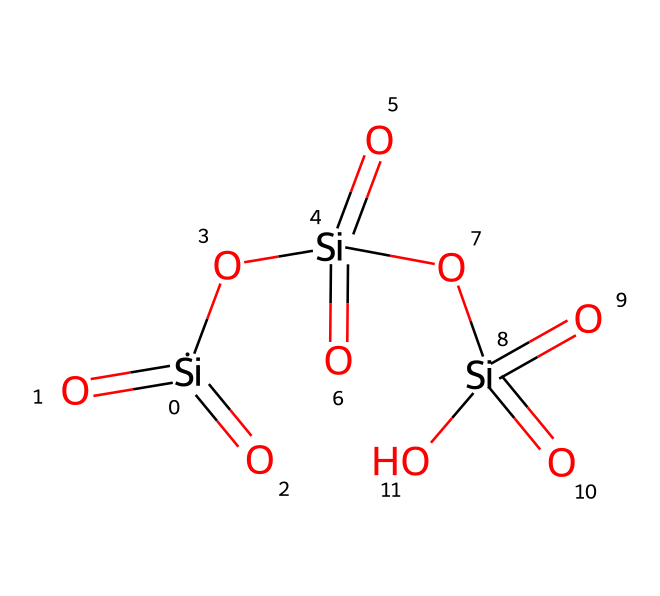How many silicon atoms are present in the structure? The SMILES representation shows three instances of the silicon atom (Si), which are clearly depicted in the structure. Each silicon is bonded with oxygen and a hydroxyl group.
Answer: three What is the total number of oxygen atoms in the chemical? Analyzing the SMILES structure, each silicon atom is surrounded by four oxygen atoms: three from the silicate bonds and one as a hydroxyl (OH). Therefore, the total count is three silicon atoms multiplied by four oxygen atoms, resulting in twelve oxygen atoms.
Answer: twelve What type of chemical structure does silicon dioxide have? The visual representation indicates a tetrahedral coordination, typical for silicon dioxide, with silicon atoms surrounded by oxygen atoms forming a networked structure that contributes to its properties.
Answer: tetrahedral Does this structure show any hydrogen atoms? The chemical appears to have hydroxyl groups (OH), indicating the presence of hydrogen atoms, but specifically in the listed SMILES, there are no explicitly represented hydrogen atoms outside of those in hydroxyl groups.
Answer: yes What crystal system is silicon dioxide typically associated with? Silicon dioxide commonly crystallizes in a tetragonal or hexagonal system depending on its form (quartz or tridymite, respectively). Therefore, it typically fits into one of these crystal systems based on its arrangement.
Answer: tetragonal Is this structure likely to contribute to soundproofing materials? The resilience and structural integrity of silicon dioxide in the form used for studio applications allow it to effectively dampen sound vibrations, thereby serving an important role in soundproofing.
Answer: yes 